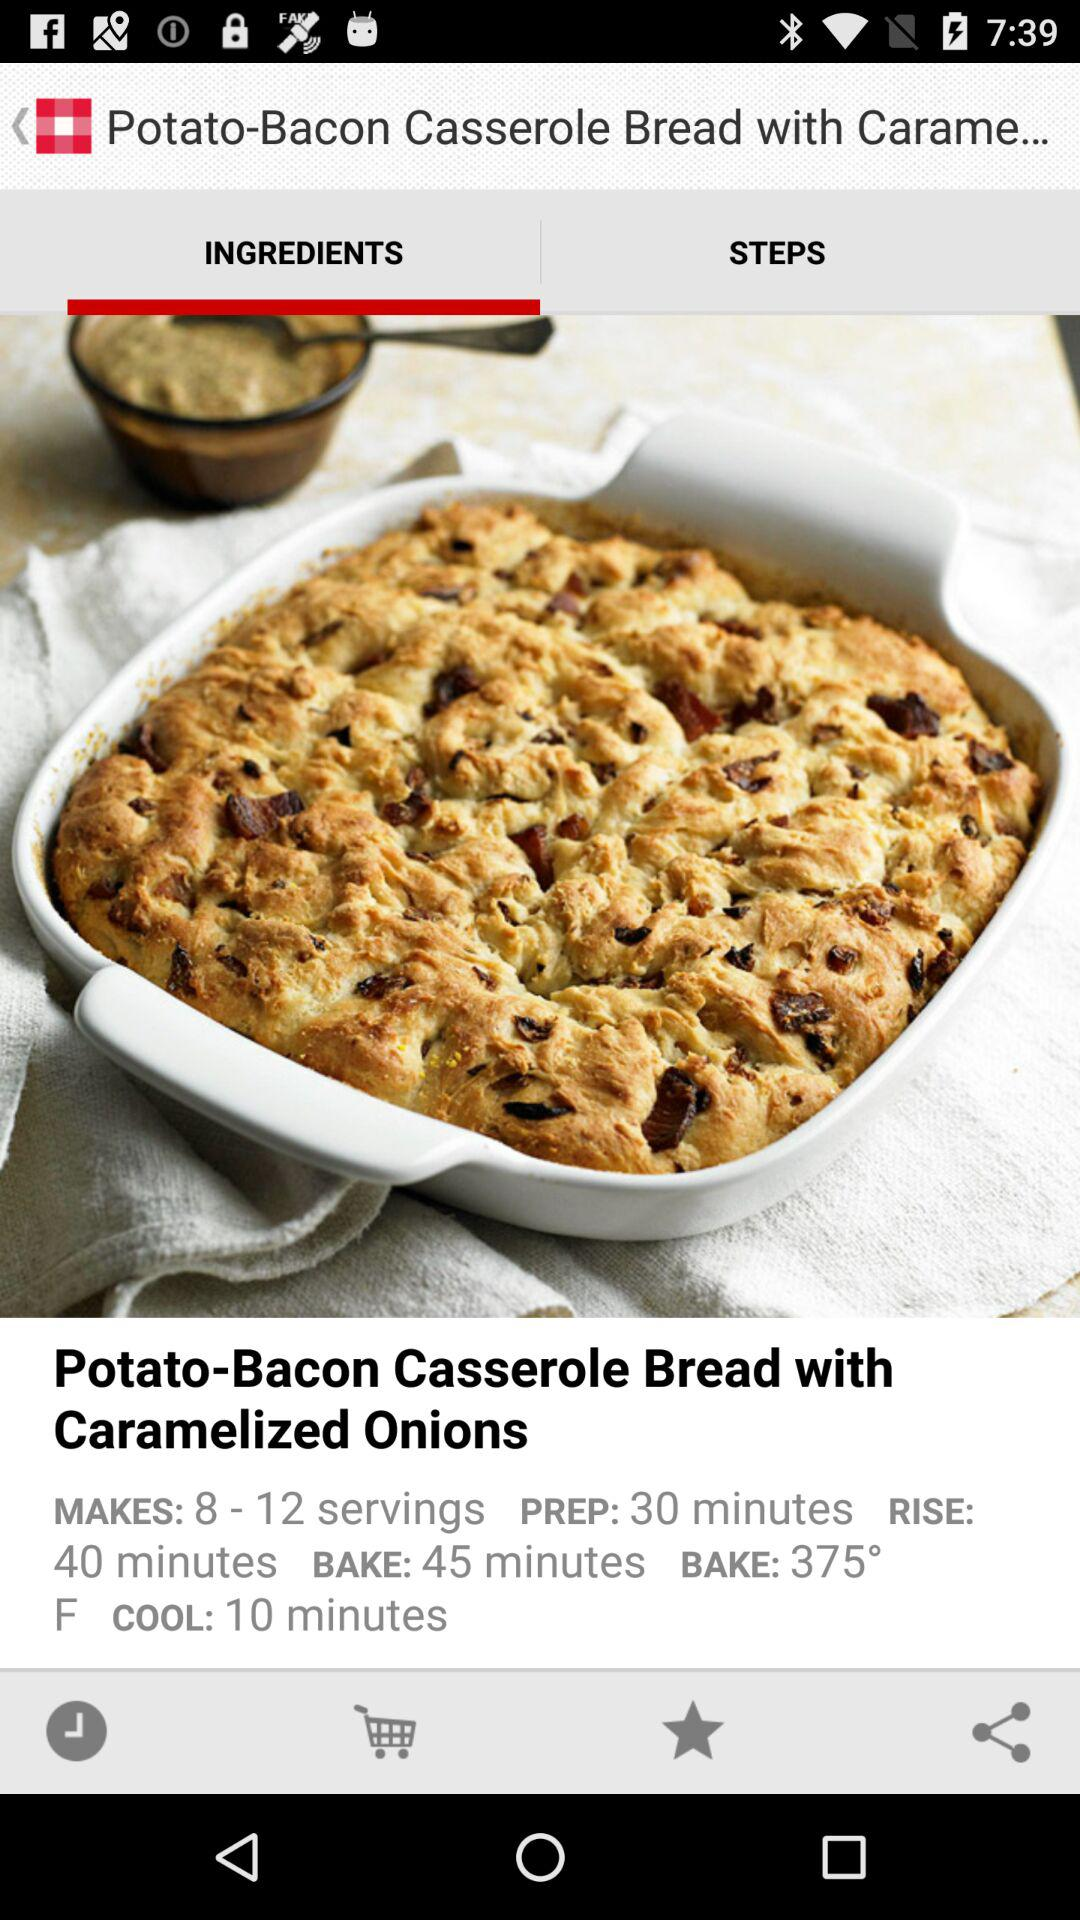What is the preparation time of the food Potato-Bacon Casserole Bread with Caramelized Onions? The preparation time is 30 minutes. 